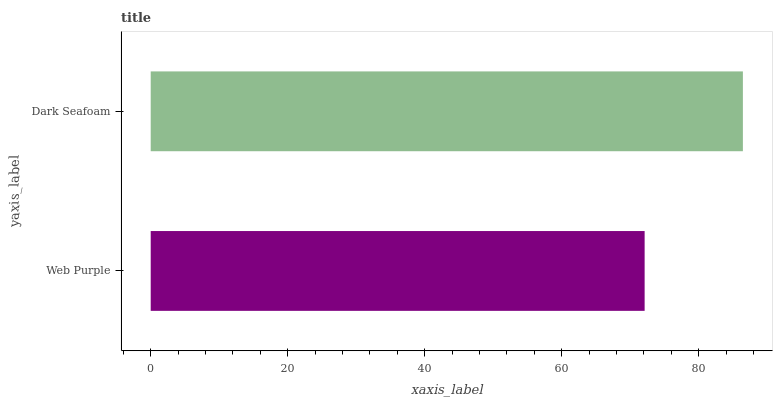Is Web Purple the minimum?
Answer yes or no. Yes. Is Dark Seafoam the maximum?
Answer yes or no. Yes. Is Dark Seafoam the minimum?
Answer yes or no. No. Is Dark Seafoam greater than Web Purple?
Answer yes or no. Yes. Is Web Purple less than Dark Seafoam?
Answer yes or no. Yes. Is Web Purple greater than Dark Seafoam?
Answer yes or no. No. Is Dark Seafoam less than Web Purple?
Answer yes or no. No. Is Dark Seafoam the high median?
Answer yes or no. Yes. Is Web Purple the low median?
Answer yes or no. Yes. Is Web Purple the high median?
Answer yes or no. No. Is Dark Seafoam the low median?
Answer yes or no. No. 